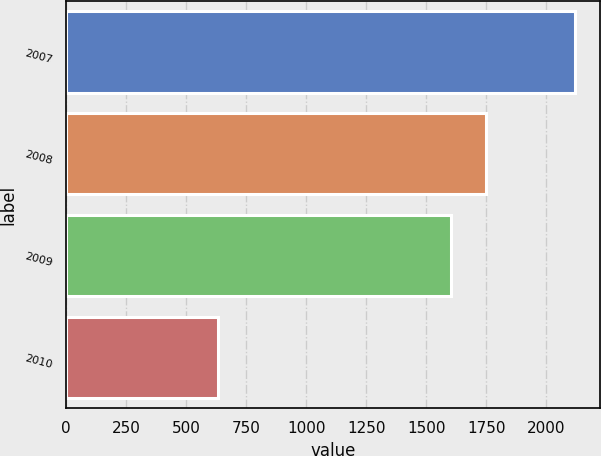<chart> <loc_0><loc_0><loc_500><loc_500><bar_chart><fcel>2007<fcel>2008<fcel>2009<fcel>2010<nl><fcel>2119<fcel>1750.7<fcel>1602<fcel>632<nl></chart> 